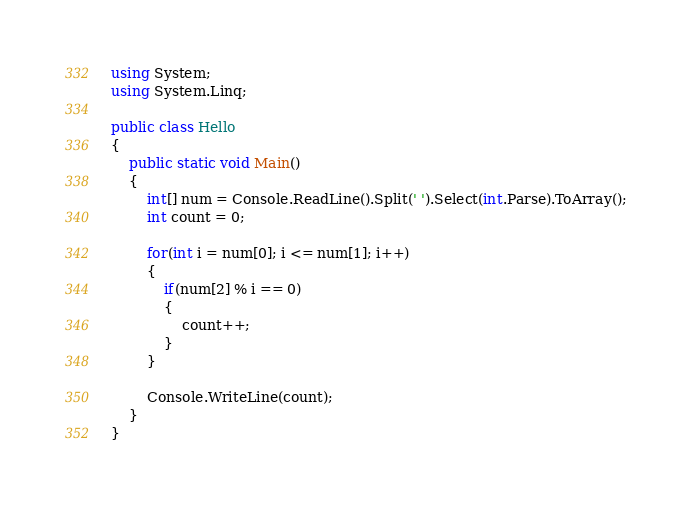Convert code to text. <code><loc_0><loc_0><loc_500><loc_500><_C#_>using System;
using System.Linq;

public class Hello
{
    public static void Main()
    {
        int[] num = Console.ReadLine().Split(' ').Select(int.Parse).ToArray();
        int count = 0;

        for(int i = num[0]; i <= num[1]; i++)
        {
            if(num[2] % i == 0)
            {
                count++;
            }
        }

        Console.WriteLine(count);
    }
}</code> 